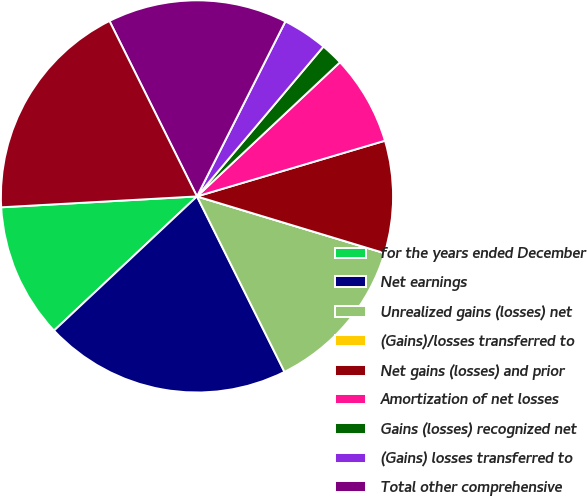<chart> <loc_0><loc_0><loc_500><loc_500><pie_chart><fcel>for the years ended December<fcel>Net earnings<fcel>Unrealized gains (losses) net<fcel>(Gains)/losses transferred to<fcel>Net gains (losses) and prior<fcel>Amortization of net losses<fcel>Gains (losses) recognized net<fcel>(Gains) losses transferred to<fcel>Total other comprehensive<fcel>Total comprehensive earnings<nl><fcel>11.11%<fcel>20.37%<fcel>12.96%<fcel>0.0%<fcel>9.26%<fcel>7.41%<fcel>1.85%<fcel>3.71%<fcel>14.81%<fcel>18.52%<nl></chart> 